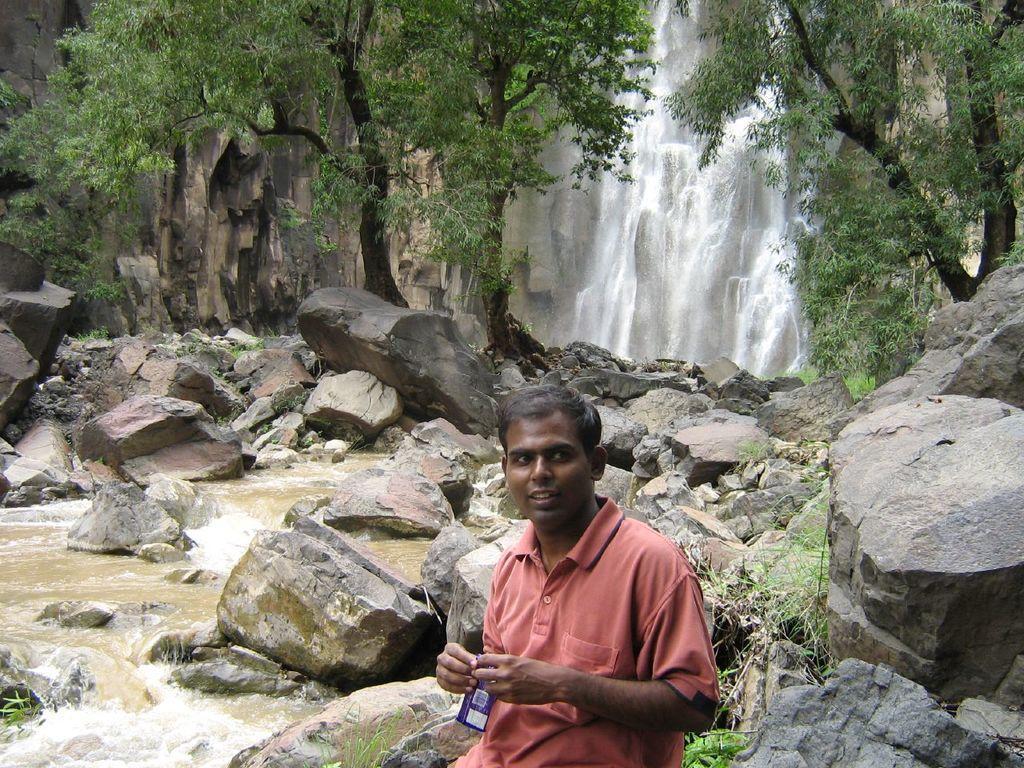Can you describe this image briefly? In the foreground of the picture there is a person, he is holding a chocolate. On the left there are rocks and water flowing. On the right there are stones and grass. In the center of the picture there are trees and stones. In the background there is a waterfall from the mountain. 